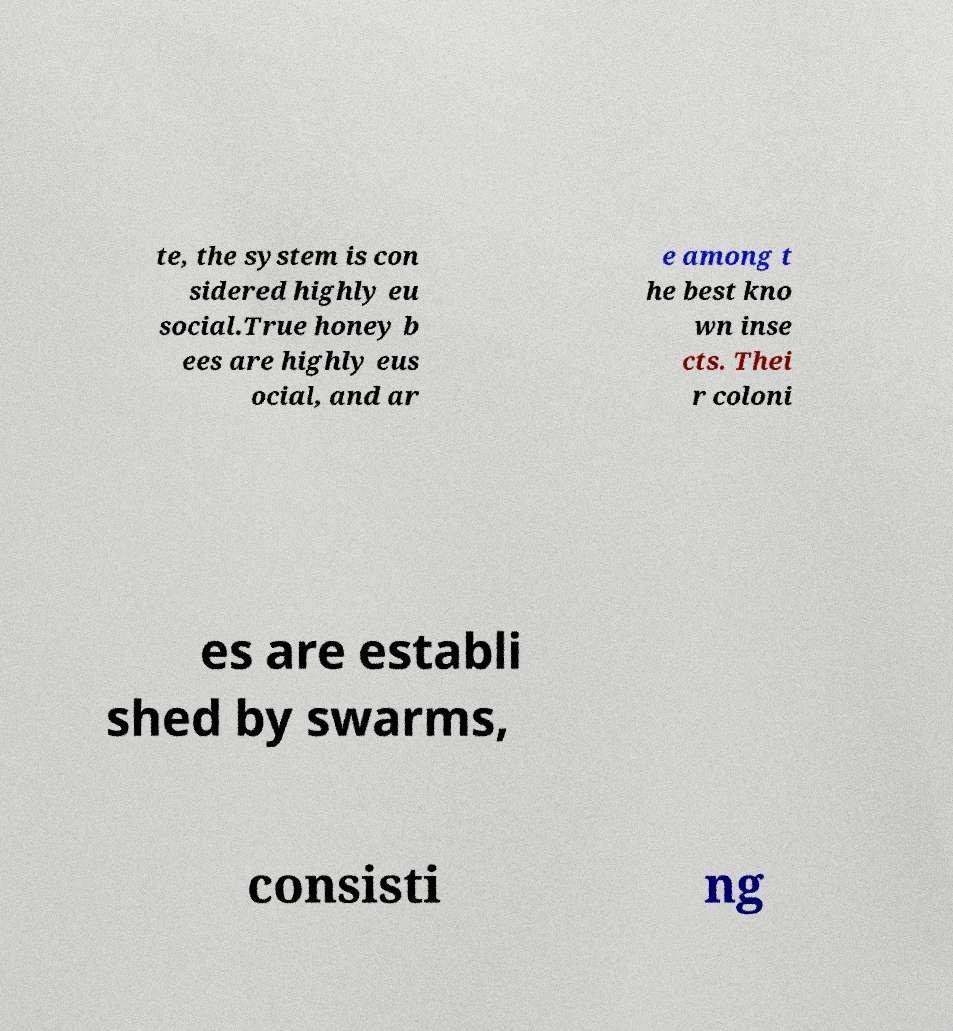Please read and relay the text visible in this image. What does it say? te, the system is con sidered highly eu social.True honey b ees are highly eus ocial, and ar e among t he best kno wn inse cts. Thei r coloni es are establi shed by swarms, consisti ng 